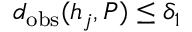Convert formula to latex. <formula><loc_0><loc_0><loc_500><loc_500>d _ { o b s } ( h _ { j } , P ) \leq \delta _ { 1 }</formula> 